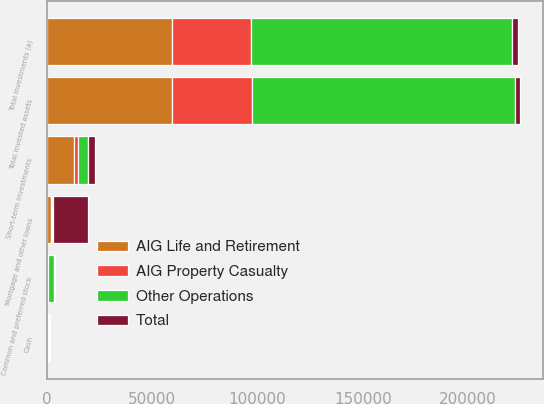Convert chart. <chart><loc_0><loc_0><loc_500><loc_500><stacked_bar_chart><ecel><fcel>Common and preferred stock<fcel>Mortgage and other loans<fcel>Short-term investments<fcel>Total investments (a)<fcel>Cash<fcel>Total invested assets<nl><fcel>Other Operations<fcel>2895<fcel>553<fcel>4660<fcel>124306<fcel>673<fcel>124979<nl><fcel>Total<fcel>208<fcel>16759<fcel>3318<fcel>2491<fcel>463<fcel>2491<nl><fcel>AIG Property Casualty<fcel>1<fcel>90<fcel>1910<fcel>37540<fcel>65<fcel>37605<nl><fcel>AIG Life and Retirement<fcel>520<fcel>2087<fcel>12684<fcel>59252<fcel>273<fcel>59525<nl></chart> 